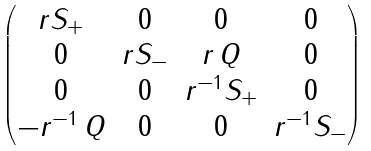Convert formula to latex. <formula><loc_0><loc_0><loc_500><loc_500>\begin{pmatrix} r S _ { + } & 0 & 0 & 0 \\ 0 & r S _ { - } & r \, Q & 0 \\ 0 & 0 & r ^ { - 1 } S _ { + } & 0 \\ - r ^ { - 1 } \, Q & 0 & 0 & r ^ { - 1 } S _ { - } \end{pmatrix}</formula> 